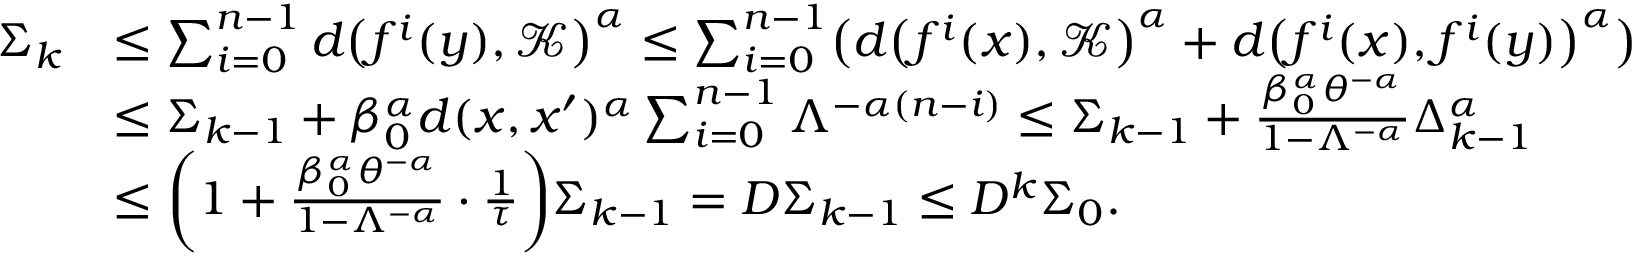<formula> <loc_0><loc_0><loc_500><loc_500>\begin{array} { r l } { \Sigma _ { k } } & { \leq \sum _ { i = 0 } ^ { n - 1 } d \left ( f ^ { i } ( y ) , \mathcal { K } \right ) ^ { \alpha } \leq \sum _ { i = 0 } ^ { n - 1 } \left ( d \left ( f ^ { i } ( x ) , \mathcal { K } \right ) ^ { \alpha } + d \left ( f ^ { i } ( x ) , f ^ { i } ( y ) \right ) ^ { \alpha } \right ) } \\ & { \leq \Sigma _ { k - 1 } + \beta _ { 0 } ^ { \alpha } d ( x , x ^ { \prime } ) ^ { \alpha } \sum _ { i = 0 } ^ { n - 1 } \Lambda ^ { - \alpha ( n - i ) } \leq \Sigma _ { k - 1 } + \frac { \beta _ { 0 } ^ { \alpha } \theta ^ { - \alpha } } { 1 - \Lambda ^ { - \alpha } } \Delta _ { k - 1 } ^ { \alpha } } \\ & { \leq \left ( 1 + \frac { \beta _ { 0 } ^ { \alpha } \theta ^ { - \alpha } } { 1 - \Lambda ^ { - \alpha } } \cdot \frac { 1 } { \tau } \right ) \Sigma _ { k - 1 } = D \Sigma _ { k - 1 } \leq D ^ { k } \Sigma _ { 0 } . } \end{array}</formula> 